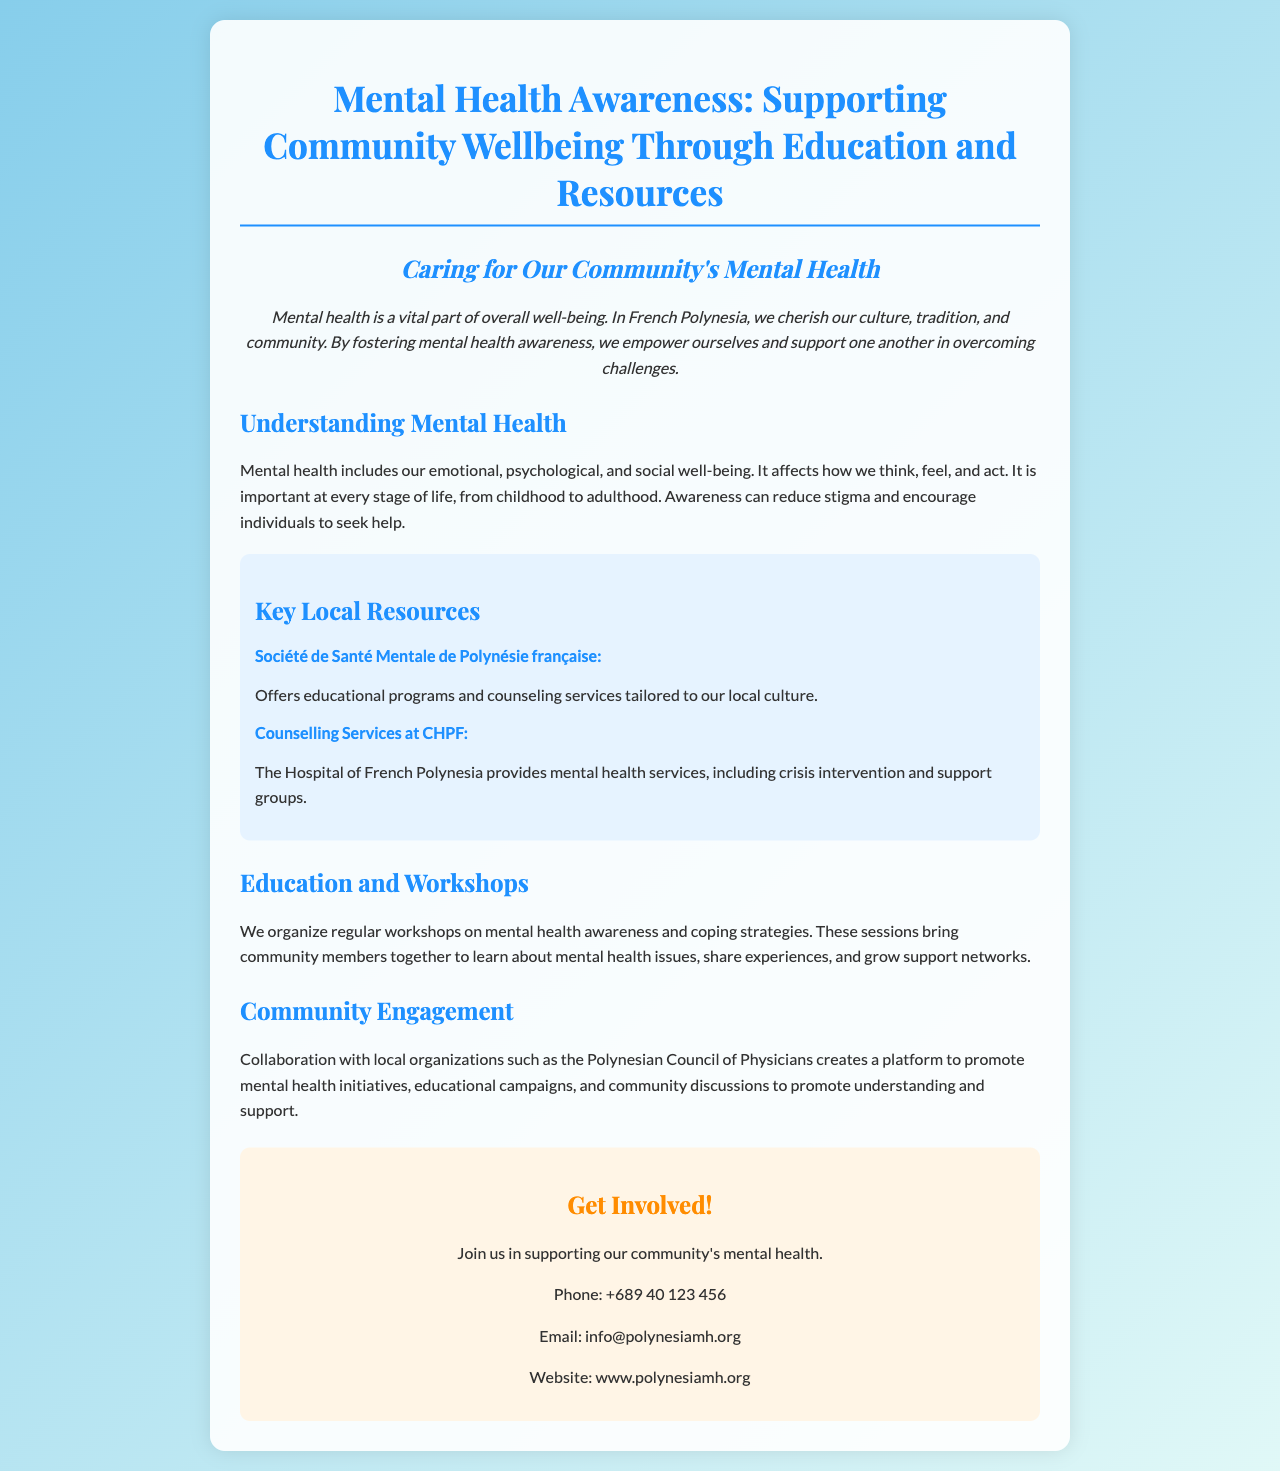what is the title of the brochure? The title of the brochure is prominently displayed at the top, stating the focus of the document.
Answer: Mental Health Awareness: Supporting Community Wellbeing Through Education and Resources what does the Société de Santé Mentale de Polynésie française offer? This organization is mentioned in the resources section, detailing its services to the community.
Answer: Educational programs and counseling services how can community members get involved? The brochure invites the community to participate actively and provides contact information for further engagement.
Answer: Join us in supporting our community's mental health what phone number is listed for contact? A specific phone number is provided in the contact section for inquiries about mental health support.
Answer: +689 40 123 456 what is one of the goals of mental health awareness according to the brochure? The document states the purpose of mental health awareness to reduce stigma and encourage help-seeking behavior.
Answer: Reduce stigma how does the brochure describe mental health? The brochure provides a definition of mental health, including its emotional, psychological, and social dimensions.
Answer: Emotional, psychological, and social well-being what type of local organization collaborates with the brochure's initiatives? The partnership is mentioned in the community engagement section, highlighting the involvement of local health professionals.
Answer: Polynesian Council of Physicians how often are workshops conducted? The brochure discusses regularity but does not specify exact frequency, implying ongoing activities.
Answer: Regular 